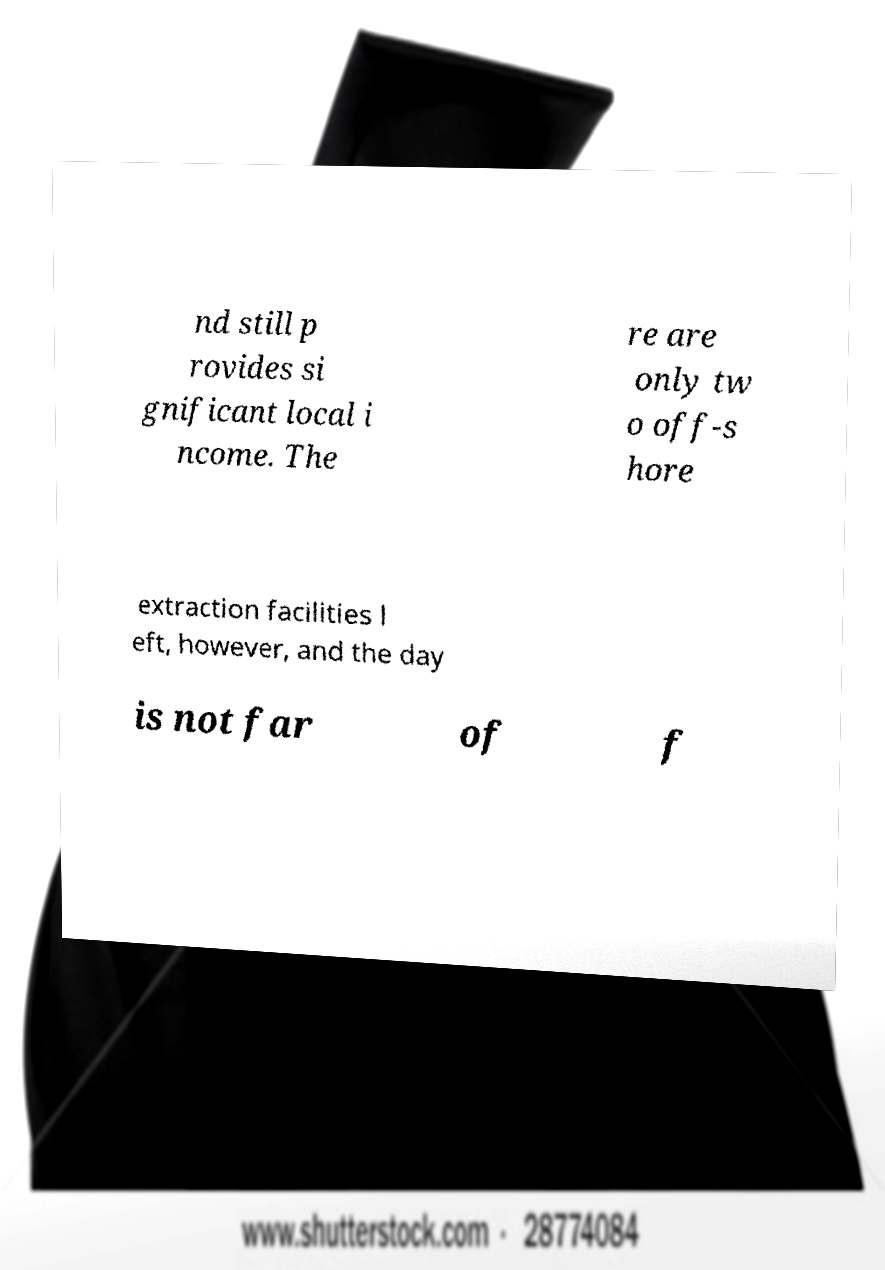Could you assist in decoding the text presented in this image and type it out clearly? nd still p rovides si gnificant local i ncome. The re are only tw o off-s hore extraction facilities l eft, however, and the day is not far of f 